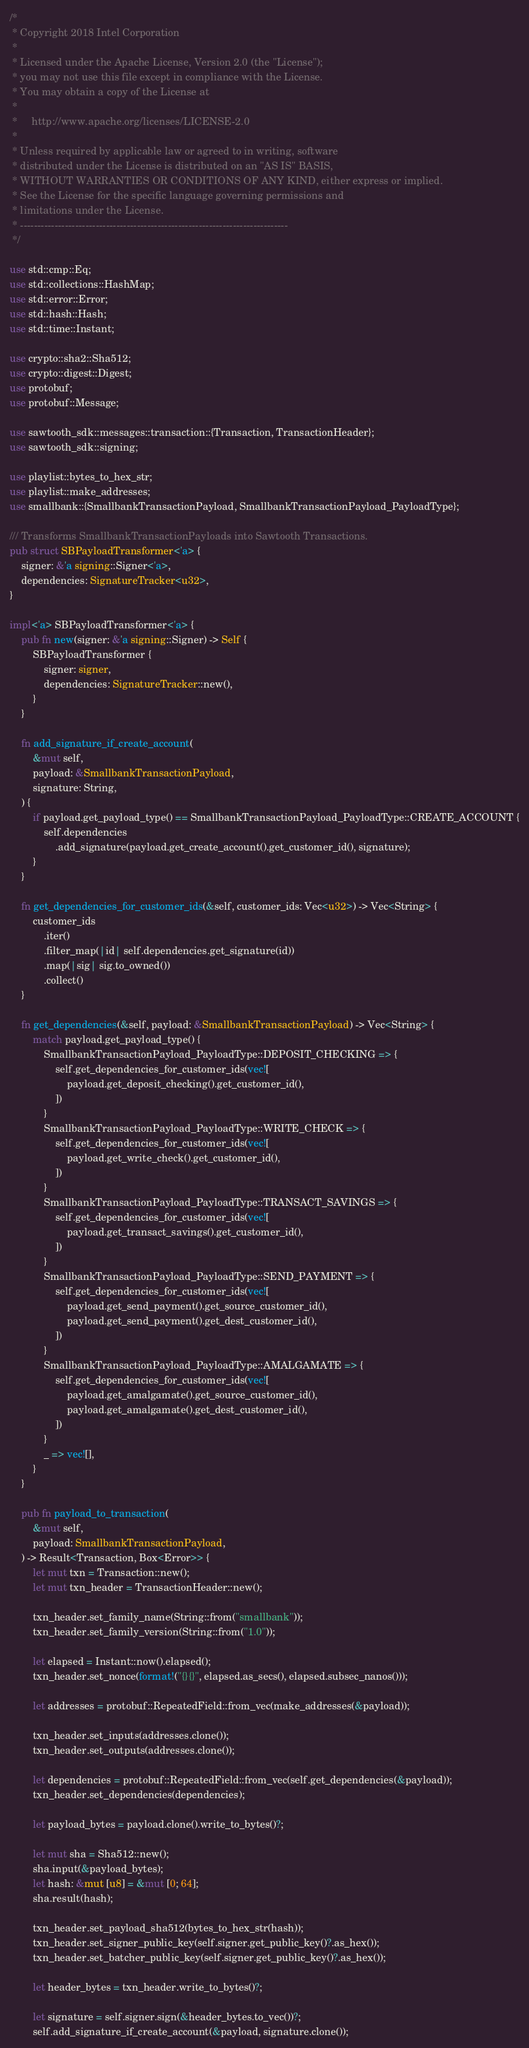<code> <loc_0><loc_0><loc_500><loc_500><_Rust_>/*
 * Copyright 2018 Intel Corporation
 *
 * Licensed under the Apache License, Version 2.0 (the "License");
 * you may not use this file except in compliance with the License.
 * You may obtain a copy of the License at
 *
 *     http://www.apache.org/licenses/LICENSE-2.0
 *
 * Unless required by applicable law or agreed to in writing, software
 * distributed under the License is distributed on an "AS IS" BASIS,
 * WITHOUT WARRANTIES OR CONDITIONS OF ANY KIND, either express or implied.
 * See the License for the specific language governing permissions and
 * limitations under the License.
 * ------------------------------------------------------------------------------
 */

use std::cmp::Eq;
use std::collections::HashMap;
use std::error::Error;
use std::hash::Hash;
use std::time::Instant;

use crypto::sha2::Sha512;
use crypto::digest::Digest;
use protobuf;
use protobuf::Message;

use sawtooth_sdk::messages::transaction::{Transaction, TransactionHeader};
use sawtooth_sdk::signing;

use playlist::bytes_to_hex_str;
use playlist::make_addresses;
use smallbank::{SmallbankTransactionPayload, SmallbankTransactionPayload_PayloadType};

/// Transforms SmallbankTransactionPayloads into Sawtooth Transactions.
pub struct SBPayloadTransformer<'a> {
    signer: &'a signing::Signer<'a>,
    dependencies: SignatureTracker<u32>,
}

impl<'a> SBPayloadTransformer<'a> {
    pub fn new(signer: &'a signing::Signer) -> Self {
        SBPayloadTransformer {
            signer: signer,
            dependencies: SignatureTracker::new(),
        }
    }

    fn add_signature_if_create_account(
        &mut self,
        payload: &SmallbankTransactionPayload,
        signature: String,
    ) {
        if payload.get_payload_type() == SmallbankTransactionPayload_PayloadType::CREATE_ACCOUNT {
            self.dependencies
                .add_signature(payload.get_create_account().get_customer_id(), signature);
        }
    }

    fn get_dependencies_for_customer_ids(&self, customer_ids: Vec<u32>) -> Vec<String> {
        customer_ids
            .iter()
            .filter_map(|id| self.dependencies.get_signature(id))
            .map(|sig| sig.to_owned())
            .collect()
    }

    fn get_dependencies(&self, payload: &SmallbankTransactionPayload) -> Vec<String> {
        match payload.get_payload_type() {
            SmallbankTransactionPayload_PayloadType::DEPOSIT_CHECKING => {
                self.get_dependencies_for_customer_ids(vec![
                    payload.get_deposit_checking().get_customer_id(),
                ])
            }
            SmallbankTransactionPayload_PayloadType::WRITE_CHECK => {
                self.get_dependencies_for_customer_ids(vec![
                    payload.get_write_check().get_customer_id(),
                ])
            }
            SmallbankTransactionPayload_PayloadType::TRANSACT_SAVINGS => {
                self.get_dependencies_for_customer_ids(vec![
                    payload.get_transact_savings().get_customer_id(),
                ])
            }
            SmallbankTransactionPayload_PayloadType::SEND_PAYMENT => {
                self.get_dependencies_for_customer_ids(vec![
                    payload.get_send_payment().get_source_customer_id(),
                    payload.get_send_payment().get_dest_customer_id(),
                ])
            }
            SmallbankTransactionPayload_PayloadType::AMALGAMATE => {
                self.get_dependencies_for_customer_ids(vec![
                    payload.get_amalgamate().get_source_customer_id(),
                    payload.get_amalgamate().get_dest_customer_id(),
                ])
            }
            _ => vec![],
        }
    }

    pub fn payload_to_transaction(
        &mut self,
        payload: SmallbankTransactionPayload,
    ) -> Result<Transaction, Box<Error>> {
        let mut txn = Transaction::new();
        let mut txn_header = TransactionHeader::new();

        txn_header.set_family_name(String::from("smallbank"));
        txn_header.set_family_version(String::from("1.0"));

        let elapsed = Instant::now().elapsed();
        txn_header.set_nonce(format!("{}{}", elapsed.as_secs(), elapsed.subsec_nanos()));

        let addresses = protobuf::RepeatedField::from_vec(make_addresses(&payload));

        txn_header.set_inputs(addresses.clone());
        txn_header.set_outputs(addresses.clone());

        let dependencies = protobuf::RepeatedField::from_vec(self.get_dependencies(&payload));
        txn_header.set_dependencies(dependencies);

        let payload_bytes = payload.clone().write_to_bytes()?;

        let mut sha = Sha512::new();
        sha.input(&payload_bytes);
        let hash: &mut [u8] = &mut [0; 64];
        sha.result(hash);

        txn_header.set_payload_sha512(bytes_to_hex_str(hash));
        txn_header.set_signer_public_key(self.signer.get_public_key()?.as_hex());
        txn_header.set_batcher_public_key(self.signer.get_public_key()?.as_hex());

        let header_bytes = txn_header.write_to_bytes()?;

        let signature = self.signer.sign(&header_bytes.to_vec())?;
        self.add_signature_if_create_account(&payload, signature.clone());
</code> 